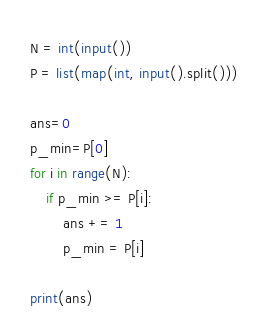Convert code to text. <code><loc_0><loc_0><loc_500><loc_500><_Python_>N = int(input())
P = list(map(int, input().split()))

ans=0
p_min=P[0]
for i in range(N):
    if p_min >= P[i]:
        ans += 1
        p_min = P[i]

print(ans)
</code> 